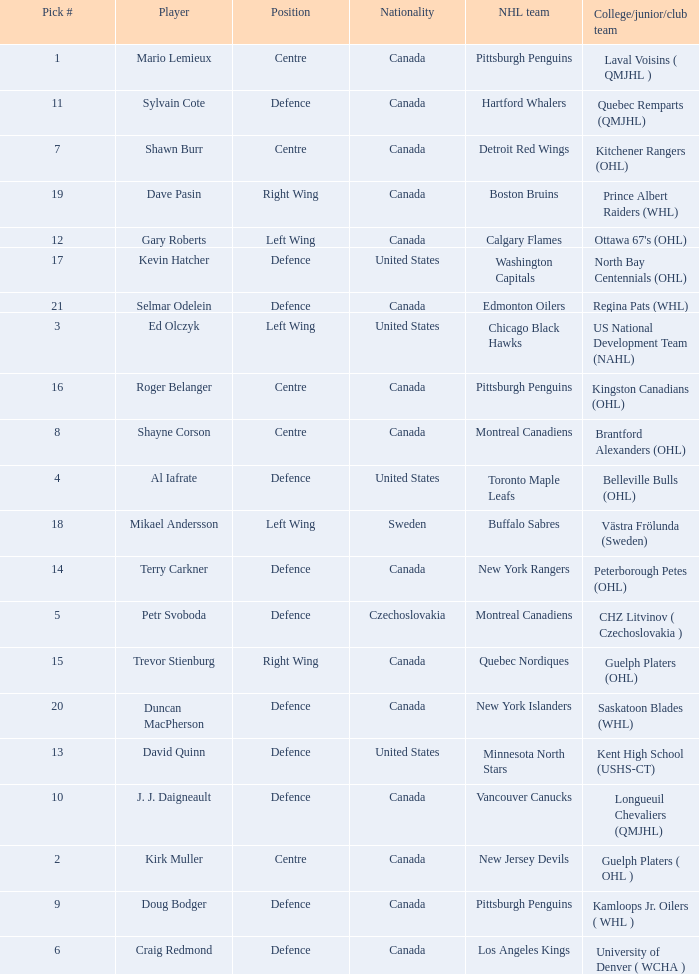What player is draft pick 17? Kevin Hatcher. 